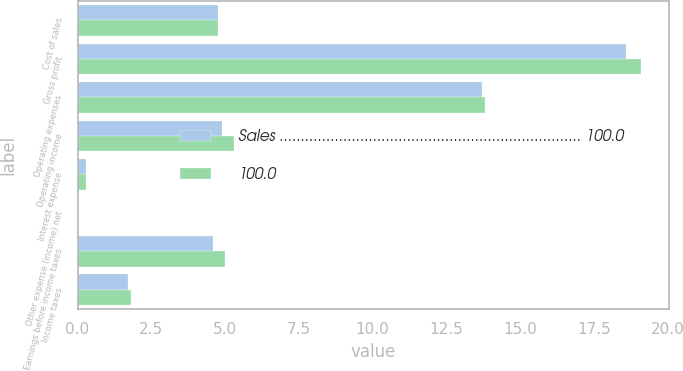Convert chart. <chart><loc_0><loc_0><loc_500><loc_500><stacked_bar_chart><ecel><fcel>Cost of sales<fcel>Gross profit<fcel>Operating expenses<fcel>Operating income<fcel>Interest expense<fcel>Other expense (income) net<fcel>Earnings before income taxes<fcel>Income taxes<nl><fcel>Sales ....................................................................... 100.0<fcel>4.75<fcel>18.6<fcel>13.7<fcel>4.9<fcel>0.3<fcel>0<fcel>4.6<fcel>1.7<nl><fcel>100.0<fcel>4.75<fcel>19.1<fcel>13.8<fcel>5.3<fcel>0.3<fcel>0<fcel>5<fcel>1.8<nl></chart> 